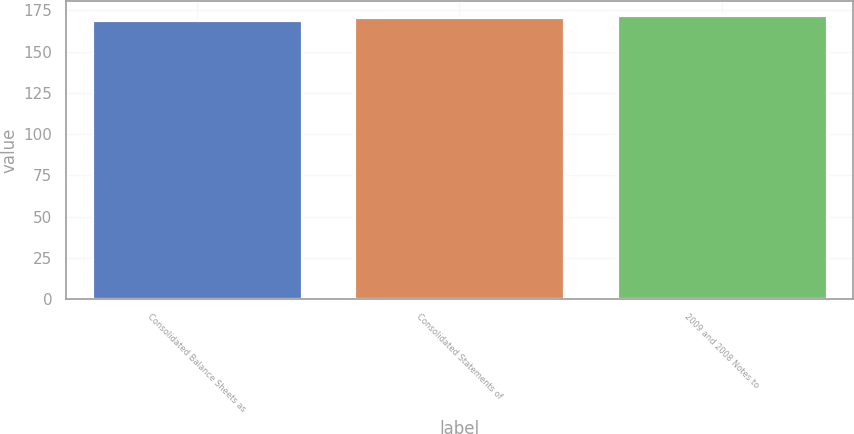Convert chart. <chart><loc_0><loc_0><loc_500><loc_500><bar_chart><fcel>Consolidated Balance Sheets as<fcel>Consolidated Statements of<fcel>2009 and 2008 Notes to<nl><fcel>169<fcel>171<fcel>172<nl></chart> 